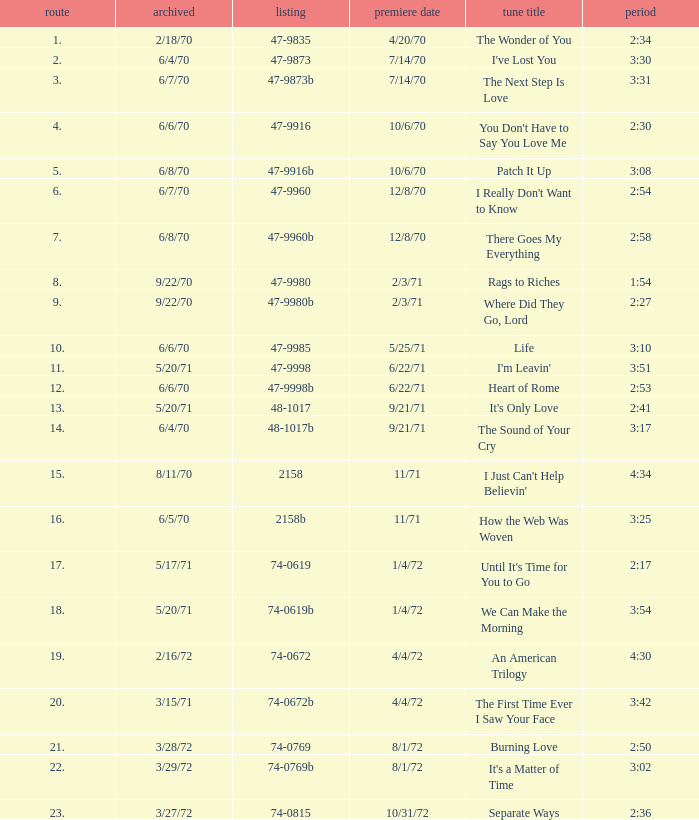What is Heart of Rome's catalogue number? 47-9998b. 